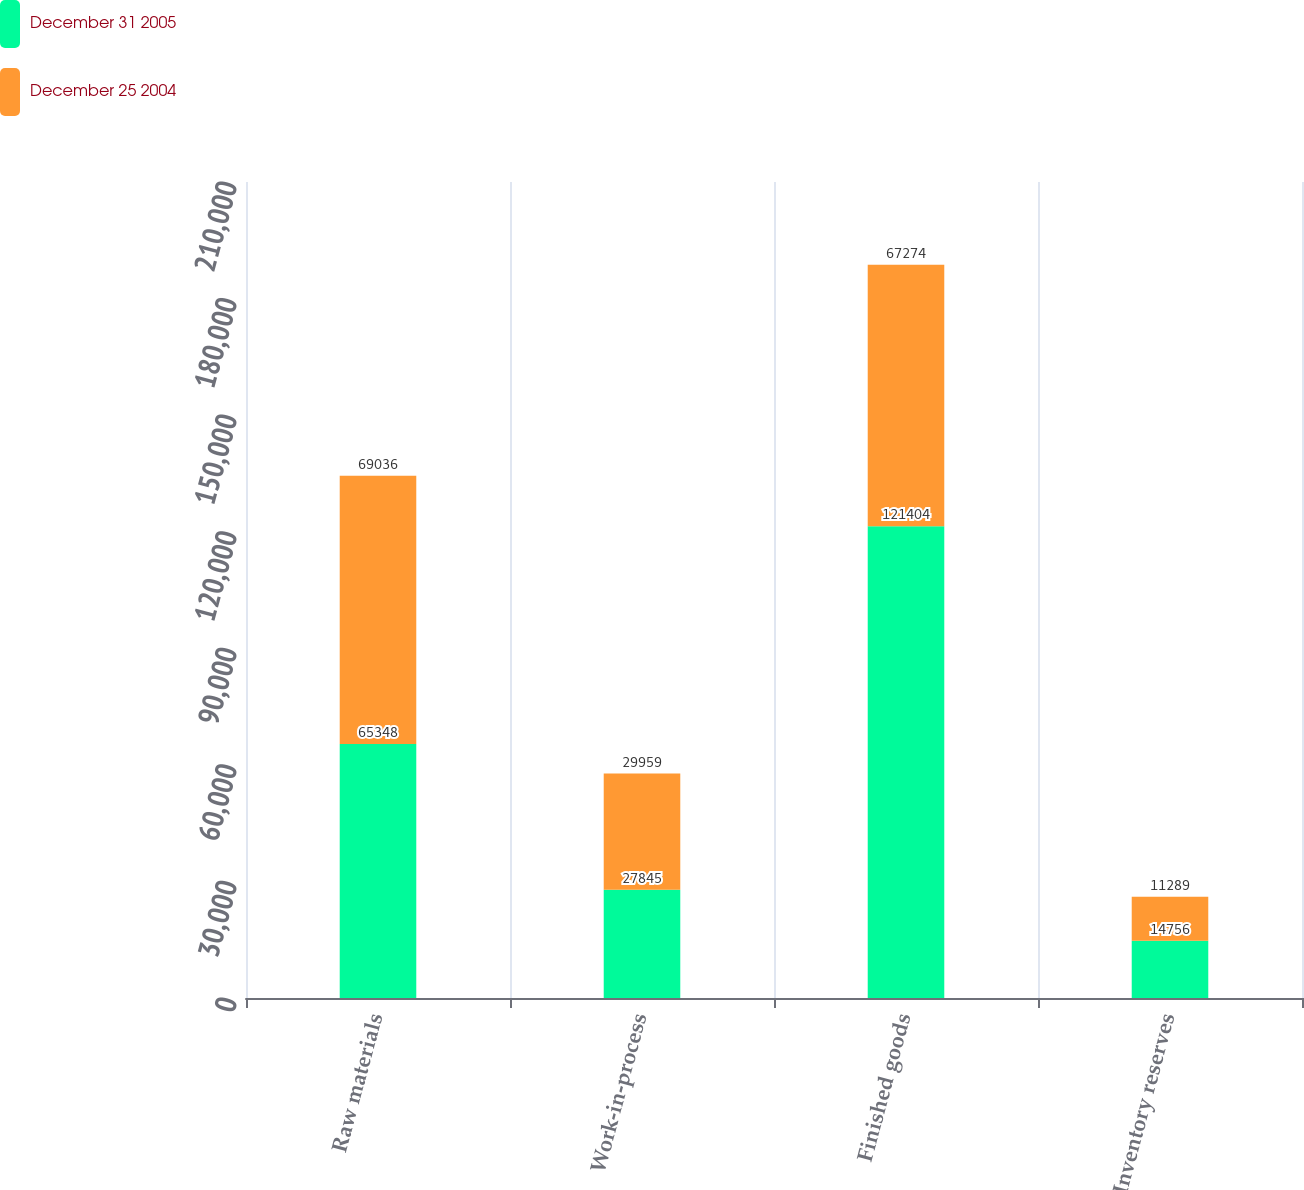Convert chart to OTSL. <chart><loc_0><loc_0><loc_500><loc_500><stacked_bar_chart><ecel><fcel>Raw materials<fcel>Work-in-process<fcel>Finished goods<fcel>Inventory reserves<nl><fcel>December 31 2005<fcel>65348<fcel>27845<fcel>121404<fcel>14756<nl><fcel>December 25 2004<fcel>69036<fcel>29959<fcel>67274<fcel>11289<nl></chart> 